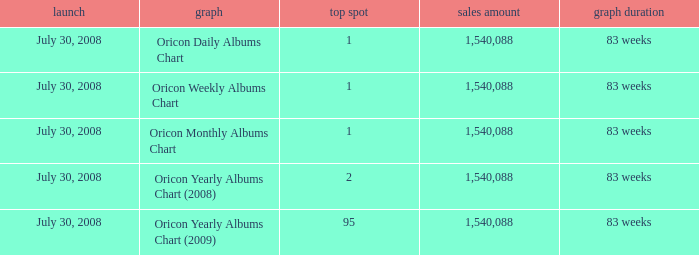Which Chart has a Peak Position of 1? Oricon Daily Albums Chart, Oricon Weekly Albums Chart, Oricon Monthly Albums Chart. 